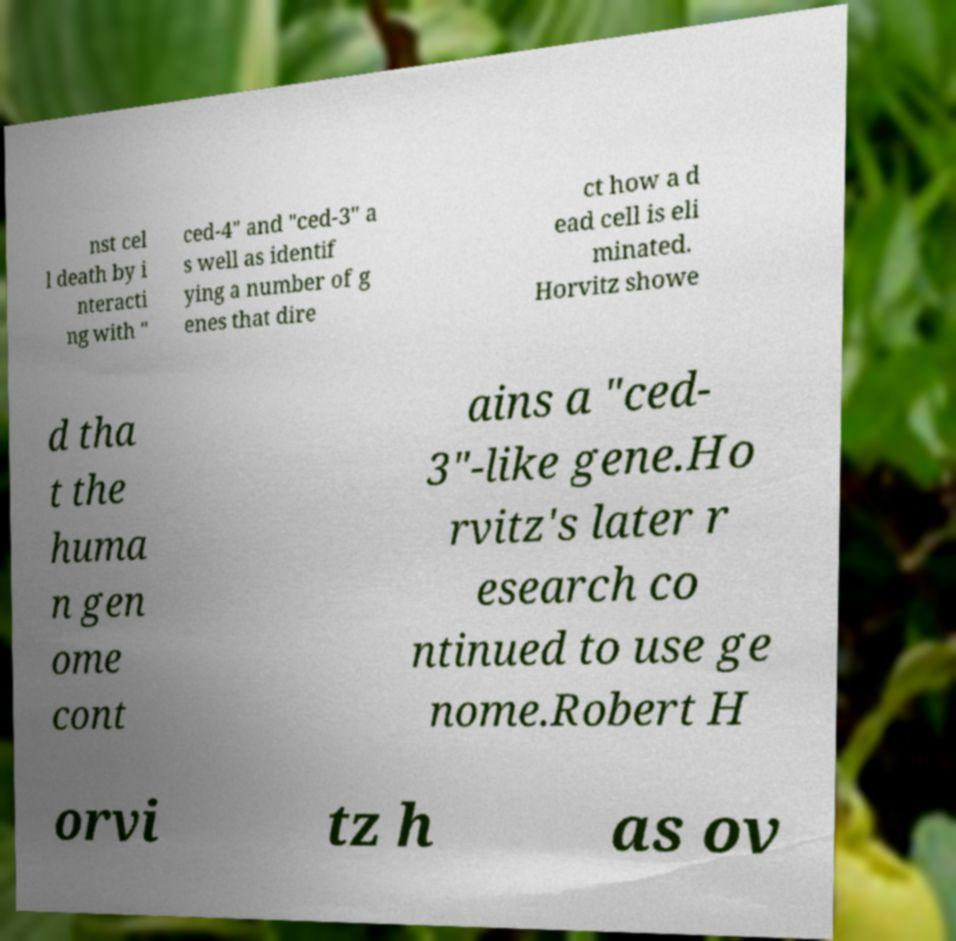Can you accurately transcribe the text from the provided image for me? nst cel l death by i nteracti ng with " ced-4" and "ced-3" a s well as identif ying a number of g enes that dire ct how a d ead cell is eli minated. Horvitz showe d tha t the huma n gen ome cont ains a "ced- 3"-like gene.Ho rvitz's later r esearch co ntinued to use ge nome.Robert H orvi tz h as ov 